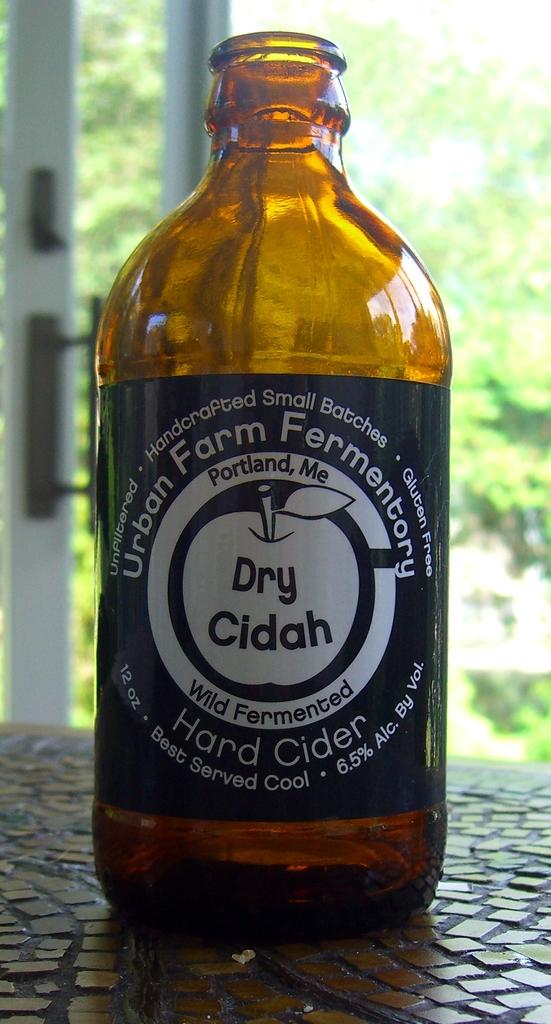What brand is the hard cider?
Provide a succinct answer. Urban farm fermentory. What kind of farm is it from?
Provide a succinct answer. Urban. 